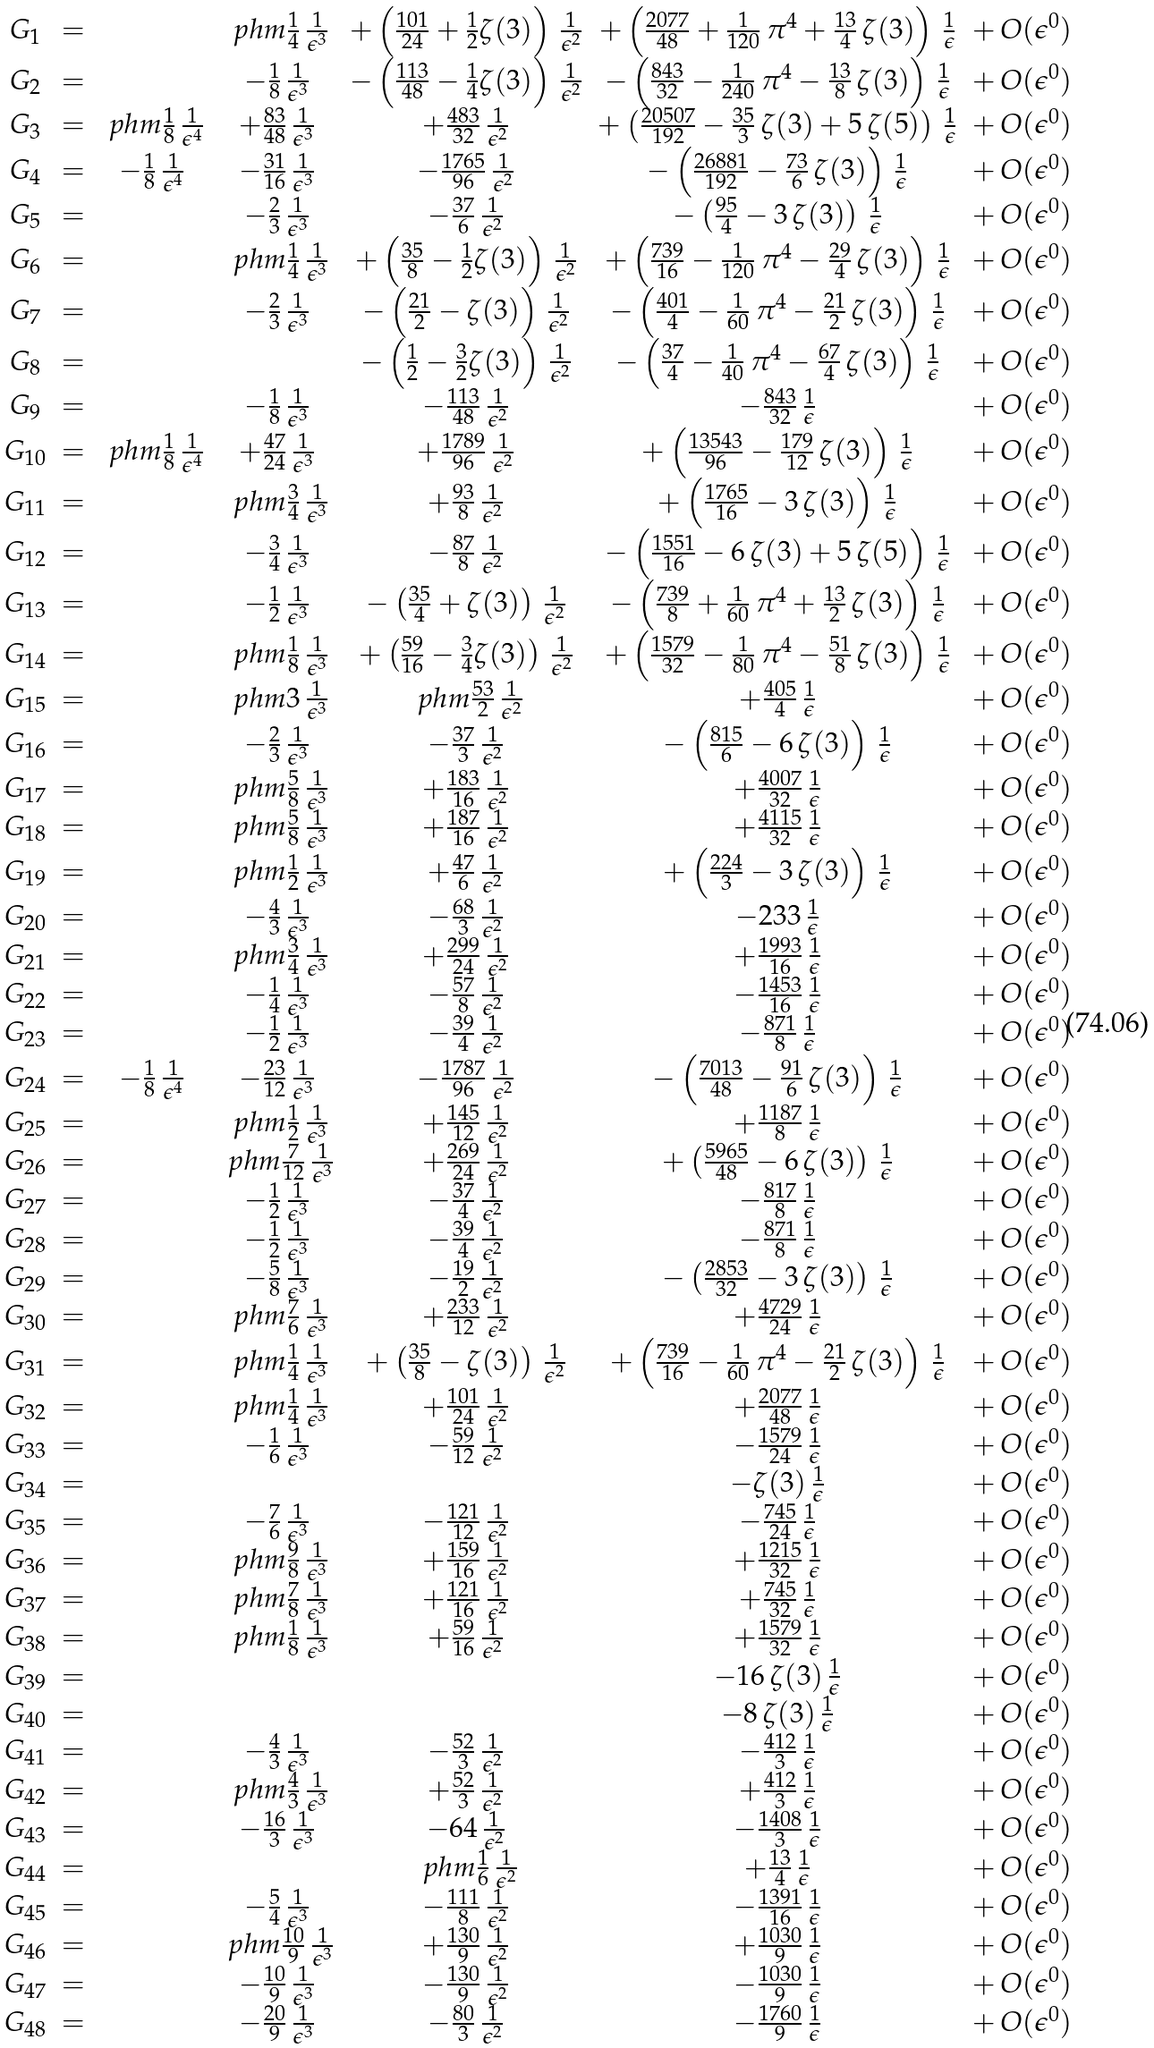Convert formula to latex. <formula><loc_0><loc_0><loc_500><loc_500>\begin{array} { c c c c c c c } G _ { 1 } & = & & \ p h m \frac { 1 } { 4 } \, \frac { 1 } { \epsilon ^ { 3 } } & + \left ( \frac { 1 0 1 } { 2 4 } + \frac { 1 } { 2 } { \text {$\zeta(3)$} } \right ) \, \frac { 1 } { \epsilon ^ { 2 } } & + \left ( \frac { 2 0 7 7 } { 4 8 } + \frac { 1 } { 1 2 0 } \, \pi ^ { 4 } + \frac { 1 3 } { 4 } \, { \text {$\zeta(3)$} } \right ) \, \frac { 1 } { \epsilon } & + \, { \text {$O(\epsilon^{0})$} } \\ G _ { 2 } & = & & - \frac { 1 } { 8 } \, \frac { 1 } { \epsilon ^ { 3 } } & - \left ( \frac { 1 1 3 } { 4 8 } - \frac { 1 } { 4 } { \text {$\zeta(3)$} } \right ) \, \frac { 1 } { \epsilon ^ { 2 } } & - \left ( \frac { 8 4 3 } { 3 2 } - \frac { 1 } { 2 4 0 } \, \pi ^ { 4 } - \frac { 1 3 } { 8 } \, { \text {$\zeta(3)$} } \right ) \, \frac { 1 } { \epsilon } & + \, { \text {$O(\epsilon^{0})$} } \\ G _ { 3 } & = & \ p h m \frac { 1 } { 8 } \, \frac { 1 } { \epsilon ^ { 4 } } & + \frac { 8 3 } { 4 8 } \, \frac { 1 } { \epsilon ^ { 3 } } & + \frac { 4 8 3 } { 3 2 } \, \frac { 1 } { \epsilon ^ { 2 } } & + \left ( \frac { 2 0 5 0 7 } { 1 9 2 } - \frac { 3 5 } { 3 } \, { \text {$\zeta(3)$} } + { \text {$5 \, \zeta (5)$} } \right ) \, \frac { 1 } { \epsilon } & + \, { \text {$O(\epsilon^{0})$} } \\ G _ { 4 } & = & - \frac { 1 } { 8 } \, \frac { 1 } { \epsilon ^ { 4 } } & - \frac { 3 1 } { 1 6 } \, \frac { 1 } { \epsilon ^ { 3 } } & - \frac { 1 7 6 5 } { 9 6 } \, \frac { 1 } { \epsilon ^ { 2 } } & - \left ( \frac { 2 6 8 8 1 } { 1 9 2 } - \frac { 7 3 } { 6 } \, { \text {$\zeta(3)$} } \right ) \, \frac { 1 } { \epsilon } & + \, { \text {$O(\epsilon^{0})$} } \\ G _ { 5 } & = & & - \frac { 2 } { 3 } \, \frac { 1 } { \epsilon ^ { 3 } } & - \frac { 3 7 } { 6 } \, \frac { 1 } { \epsilon ^ { 2 } } & - \left ( \frac { 9 5 } { 4 } - { \text {$3 \, \zeta(3)$} } \right ) \, \frac { 1 } { \epsilon } & + \, { \text {$O(\epsilon^{0})$} } \\ G _ { 6 } & = & & \ p h m \frac { 1 } { 4 } \, \frac { 1 } { \epsilon ^ { 3 } } & + \left ( \frac { 3 5 } { 8 } - \frac { 1 } { 2 } { \text {$\zeta(3)$} } \right ) \, \frac { 1 } { \epsilon ^ { 2 } } & + \left ( \frac { 7 3 9 } { 1 6 } - \frac { 1 } { 1 2 0 } \, \pi ^ { 4 } - \frac { 2 9 } { 4 } \, { \text {$\zeta(3)$} } \right ) \, \frac { 1 } { \epsilon } & + \, { \text {$O(\epsilon^{0})$} } \\ G _ { 7 } & = & & - \frac { 2 } { 3 } \, \frac { 1 } { \epsilon ^ { 3 } } & - \left ( \frac { 2 1 } { 2 } - { \text {$\zeta(3)$} } \right ) \, \frac { 1 } { \epsilon ^ { 2 } } & - \left ( \frac { 4 0 1 } { 4 } - \frac { 1 } { 6 0 } \, \pi ^ { 4 } - \frac { 2 1 } { 2 } \, { \text {$\zeta(3)$} } \right ) \, \frac { 1 } { \epsilon } & + \, { \text {$O(\epsilon^{0})$} } \\ G _ { 8 } & = & & & - \left ( \frac { 1 } { 2 } - \frac { 3 } { 2 } { \text {$\zeta(3)$} } \right ) \, \frac { 1 } { \epsilon ^ { 2 } } & - \left ( \frac { 3 7 } { 4 } - \frac { 1 } { 4 0 } \, \pi ^ { 4 } - \frac { 6 7 } { 4 } \, { \text {$\zeta(3)$} } \right ) \, \frac { 1 } { \epsilon } & + \, { \text {$O(\epsilon^{0})$} } \\ G _ { 9 } & = & & - \frac { 1 } { 8 } \, \frac { 1 } { \epsilon ^ { 3 } } & - \frac { 1 1 3 } { 4 8 } \, \frac { 1 } { \epsilon ^ { 2 } } & - \frac { 8 4 3 } { 3 2 } \, \frac { 1 } { \epsilon } & + \, { \text {$O(\epsilon^{0})$} } \\ G _ { 1 0 } & = & \ p h m \frac { 1 } { 8 } \, \frac { 1 } { \epsilon ^ { 4 } } & + \frac { 4 7 } { 2 4 } \, \frac { 1 } { \epsilon ^ { 3 } } & + \frac { 1 7 8 9 } { 9 6 } \, \frac { 1 } { \epsilon ^ { 2 } } & + \left ( \frac { 1 3 5 4 3 } { 9 6 } - \frac { 1 7 9 } { 1 2 } \, { \text {$\zeta(3)$} } \right ) \, \frac { 1 } { \epsilon } & + \, { \text {$O(\epsilon^{0})$} } \\ G _ { 1 1 } & = & & \ p h m \frac { 3 } { 4 } \, \frac { 1 } { \epsilon ^ { 3 } } & + \frac { 9 3 } { 8 } \, \frac { 1 } { \epsilon ^ { 2 } } & + \left ( \frac { 1 7 6 5 } { 1 6 } - { \text {$3 \, \zeta(3)$} } \right ) \, \frac { 1 } { \epsilon } & + \, { \text {$O(\epsilon^{0})$} } \\ G _ { 1 2 } & = & & - \frac { 3 } { 4 } \, \frac { 1 } { \epsilon ^ { 3 } } & - \frac { 8 7 } { 8 } \, \frac { 1 } { \epsilon ^ { 2 } } & - \left ( \frac { 1 5 5 1 } { 1 6 } - { \text {$6 \, \zeta(3)$} } + { \text {$5 \, \zeta (5)$} } \right ) \, \frac { 1 } { \epsilon } & + \, { \text {$O(\epsilon^{0})$} } \\ G _ { 1 3 } & = & & - \frac { 1 } { 2 } \, \frac { 1 } { \epsilon ^ { 3 } } & - \left ( \frac { 3 5 } { 4 } + { \text {$\zeta(3)$} } \right ) \, \frac { 1 } { \epsilon ^ { 2 } } & - \left ( \frac { 7 3 9 } { 8 } + \frac { 1 } { 6 0 } \, \pi ^ { 4 } + \frac { 1 3 } { 2 } \, { \text {$\zeta(3)$} } \right ) \, \frac { 1 } { \epsilon } & + \, { \text {$O(\epsilon^{0})$} } \\ G _ { 1 4 } & = & & \ p h m \frac { 1 } { 8 } \, \frac { 1 } { \epsilon ^ { 3 } } & + \left ( \frac { 5 9 } { 1 6 } - \frac { 3 } { 4 } { \text {$\zeta(3)$} } \right ) \, \frac { 1 } { \epsilon ^ { 2 } } & + \left ( \frac { 1 5 7 9 } { 3 2 } - \frac { 1 } { 8 0 } \, \pi ^ { 4 } - \frac { 5 1 } { 8 } \, { \text {$\zeta(3)$} } \right ) \, \frac { 1 } { \epsilon } & + \, { \text {$O(\epsilon^{0})$} } \\ G _ { 1 5 } & = & & \ p h m { \text {3} } \, \frac { 1 } { \epsilon ^ { 3 } } & \ p h m \frac { 5 3 } { 2 } \, \frac { 1 } { \epsilon ^ { 2 } } & + \frac { 4 0 5 } { 4 } \, \frac { 1 } { \epsilon } & + \, { \text {$O(\epsilon^{0})$} } \\ G _ { 1 6 } & = & & - \frac { 2 } { 3 } \, \frac { 1 } { \epsilon ^ { 3 } } & - \frac { 3 7 } { 3 } \, \frac { 1 } { \epsilon ^ { 2 } } & - \left ( \frac { 8 1 5 } { 6 } - { \text {$6 \, \zeta(3)$} } \right ) \, \frac { 1 } { \epsilon } & + \, { \text {$O(\epsilon^{0})$} } \\ G _ { 1 7 } & = & & \ p h m \frac { 5 } { 8 } \, \frac { 1 } { \epsilon ^ { 3 } } & + \frac { 1 8 3 } { 1 6 } \, \frac { 1 } { \epsilon ^ { 2 } } & + \frac { 4 0 0 7 } { 3 2 } \, \frac { 1 } { \epsilon } & + \, { \text {$O(\epsilon^{0})$} } \\ G _ { 1 8 } & = & & \ p h m \frac { 5 } { 8 } \, \frac { 1 } { \epsilon ^ { 3 } } & + \frac { 1 8 7 } { 1 6 } \, \frac { 1 } { \epsilon ^ { 2 } } & + \frac { 4 1 1 5 } { 3 2 } \, \frac { 1 } { \epsilon } & + \, { \text {$O(\epsilon^{0})$} } \\ G _ { 1 9 } & = & & \ p h m \frac { 1 } { 2 } \, \frac { 1 } { \epsilon ^ { 3 } } & + \frac { 4 7 } { 6 } \, \frac { 1 } { \epsilon ^ { 2 } } & + \left ( \frac { 2 2 4 } { 3 } - { \text {$3 \, \zeta(3)$} } \right ) \, \frac { 1 } { \epsilon } & + \, { \text {$O(\epsilon^{0})$} } \\ G _ { 2 0 } & = & & - \frac { 4 } { 3 } \, \frac { 1 } { \epsilon ^ { 3 } } & - \frac { 6 8 } { 3 } \, \frac { 1 } { \epsilon ^ { 2 } } & - { \text {233} } \, \frac { 1 } { \epsilon } & + \, { \text {$O(\epsilon^{0})$} } \\ G _ { 2 1 } & = & & \ p h m \frac { 3 } { 4 } \, \frac { 1 } { \epsilon ^ { 3 } } & + \frac { 2 9 9 } { 2 4 } \, \frac { 1 } { \epsilon ^ { 2 } } & + \frac { 1 9 9 3 } { 1 6 } \, \frac { 1 } { \epsilon } & + \, { \text {$O(\epsilon^{0})$} } \\ G _ { 2 2 } & = & & - \frac { 1 } { 4 } \, \frac { 1 } { \epsilon ^ { 3 } } & - \frac { 5 7 } { 8 } \, \frac { 1 } { \epsilon ^ { 2 } } & - \frac { 1 4 5 3 } { 1 6 } \, \frac { 1 } { \epsilon } & + \, { \text {$O(\epsilon^{0})$} } \\ G _ { 2 3 } & = & & - \frac { 1 } { 2 } \, \frac { 1 } { \epsilon ^ { 3 } } & - \frac { 3 9 } { 4 } \, \frac { 1 } { \epsilon ^ { 2 } } & - \frac { 8 7 1 } { 8 } \, \frac { 1 } { \epsilon } & + \, { \text {$O(\epsilon^{0})$} } \\ G _ { 2 4 } & = & - \frac { 1 } { 8 } \, \frac { 1 } { \epsilon ^ { 4 } } & - \frac { 2 3 } { 1 2 } \, \frac { 1 } { \epsilon ^ { 3 } } & - \frac { 1 7 8 7 } { 9 6 } \, \frac { 1 } { \epsilon ^ { 2 } } & - \left ( \frac { 7 0 1 3 } { 4 8 } - \frac { 9 1 } { 6 } \, { \text {$\zeta(3)$} } \right ) \, \frac { 1 } { \epsilon } & + \, { \text {$O(\epsilon^{0})$} } \\ G _ { 2 5 } & = & & \ p h m \frac { 1 } { 2 } \, \frac { 1 } { \epsilon ^ { 3 } } & + \frac { 1 4 5 } { 1 2 } \, \frac { 1 } { \epsilon ^ { 2 } } & + \frac { 1 1 8 7 } { 8 } \, \frac { 1 } { \epsilon } & + \, { \text {$O(\epsilon^{0})$} } \\ G _ { 2 6 } & = & & \ p h m \frac { 7 } { 1 2 } \, \frac { 1 } { \epsilon ^ { 3 } } & + \frac { 2 6 9 } { 2 4 } \, \frac { 1 } { \epsilon ^ { 2 } } & + \left ( \frac { 5 9 6 5 } { 4 8 } - { \text {$6 \, \zeta(3)$} } \right ) \, \frac { 1 } { \epsilon } & + \, { \text {$O(\epsilon^{0})$} } \\ G _ { 2 7 } & = & & - \frac { 1 } { 2 } \, \frac { 1 } { \epsilon ^ { 3 } } & - \frac { 3 7 } { 4 } \, \frac { 1 } { \epsilon ^ { 2 } } & - \frac { 8 1 7 } { 8 } \, \frac { 1 } { \epsilon } & + \, { \text {$O(\epsilon^{0})$} } \\ G _ { 2 8 } & = & & - \frac { 1 } { 2 } \, \frac { 1 } { \epsilon ^ { 3 } } & - \frac { 3 9 } { 4 } \, \frac { 1 } { \epsilon ^ { 2 } } & - \frac { 8 7 1 } { 8 } \, \frac { 1 } { \epsilon } & + \, { \text {$O(\epsilon^{0})$} } \\ G _ { 2 9 } & = & & - \frac { 5 } { 8 } \, \frac { 1 } { \epsilon ^ { 3 } } & - \frac { 1 9 } { 2 } \, \frac { 1 } { \epsilon ^ { 2 } } & - \left ( \frac { 2 8 5 3 } { 3 2 } - { \text {$3 \, \zeta(3)$} } \right ) \, \frac { 1 } { \epsilon } & + \, { \text {$O(\epsilon^{0})$} } \\ G _ { 3 0 } & = & & \ p h m \frac { 7 } { 6 } \, \frac { 1 } { \epsilon ^ { 3 } } & + \frac { 2 3 3 } { 1 2 } \, \frac { 1 } { \epsilon ^ { 2 } } & + \frac { 4 7 2 9 } { 2 4 } \, \frac { 1 } { \epsilon } & + \, { \text {$O(\epsilon^{0})$} } \\ G _ { 3 1 } & = & & \ p h m \frac { 1 } { 4 } \, \frac { 1 } { \epsilon ^ { 3 } } & + \left ( \frac { 3 5 } { 8 } - { \text {$\zeta(3)$} } \right ) \, \frac { 1 } { \epsilon ^ { 2 } } & + \left ( \frac { 7 3 9 } { 1 6 } - \frac { 1 } { 6 0 } \, \pi ^ { 4 } - \frac { 2 1 } { 2 } \, { \text {$\zeta(3)$} } \right ) \, \frac { 1 } { \epsilon } & + \, { \text {$O(\epsilon^{0})$} } \\ G _ { 3 2 } & = & & \ p h m \frac { 1 } { 4 } \, \frac { 1 } { \epsilon ^ { 3 } } & + \frac { 1 0 1 } { 2 4 } \, \frac { 1 } { \epsilon ^ { 2 } } & + \frac { 2 0 7 7 } { 4 8 } \, \frac { 1 } { \epsilon } & + \, { \text {$O(\epsilon^{0})$} } \\ G _ { 3 3 } & = & & - \frac { 1 } { 6 } \, \frac { 1 } { \epsilon ^ { 3 } } & - \frac { 5 9 } { 1 2 } \, \frac { 1 } { \epsilon ^ { 2 } } & - \frac { 1 5 7 9 } { 2 4 } \, \frac { 1 } { \epsilon } & + \, { \text {$O(\epsilon^{0})$} } \\ G _ { 3 4 } & = & & & & - { \text {$\zeta(3)$} } \, \frac { 1 } { \epsilon } & + \, { \text {$O(\epsilon^{0})$} } \\ G _ { 3 5 } & = & & - \frac { 7 } { 6 } \, \frac { 1 } { \epsilon ^ { 3 } } & - \frac { 1 2 1 } { 1 2 } \, \frac { 1 } { \epsilon ^ { 2 } } & - \frac { 7 4 5 } { 2 4 } \, \frac { 1 } { \epsilon } & + \, { \text {$O(\epsilon^{0})$} } \\ G _ { 3 6 } & = & & \ p h m \frac { 9 } { 8 } \, \frac { 1 } { \epsilon ^ { 3 } } & + \frac { 1 5 9 } { 1 6 } \, \frac { 1 } { \epsilon ^ { 2 } } & + \frac { 1 2 1 5 } { 3 2 } \, \frac { 1 } { \epsilon } & + \, { \text {$O(\epsilon^{0})$} } \\ G _ { 3 7 } & = & & \ p h m \frac { 7 } { 8 } \, \frac { 1 } { \epsilon ^ { 3 } } & + \frac { 1 2 1 } { 1 6 } \, \frac { 1 } { \epsilon ^ { 2 } } & + \frac { 7 4 5 } { 3 2 } \, \frac { 1 } { \epsilon } & + \, { \text {$O(\epsilon^{0})$} } \\ G _ { 3 8 } & = & & \ p h m \frac { 1 } { 8 } \, \frac { 1 } { \epsilon ^ { 3 } } & + \frac { 5 9 } { 1 6 } \, \frac { 1 } { \epsilon ^ { 2 } } & + \frac { 1 5 7 9 } { 3 2 } \, \frac { 1 } { \epsilon } & + \, { \text {$O(\epsilon^{0})$} } \\ G _ { 3 9 } & = & & & & - { \text {$16 \, \zeta(3)$} } \, \frac { 1 } { \epsilon } & + \, { \text {$O(\epsilon^{0})$} } \\ G _ { 4 0 } & = & & & & - { \text {$8 \, \zeta(3)$} } \, \frac { 1 } { \epsilon } & + \, { \text {$O(\epsilon^{0})$} } \\ G _ { 4 1 } & = & & - \frac { 4 } { 3 } \, \frac { 1 } { \epsilon ^ { 3 } } & - \frac { 5 2 } { 3 } \, \frac { 1 } { \epsilon ^ { 2 } } & - \frac { 4 1 2 } { 3 } \, \frac { 1 } { \epsilon } & + \, { \text {$O(\epsilon^{0})$} } \\ G _ { 4 2 } & = & & \ p h m \frac { 4 } { 3 } \, \frac { 1 } { \epsilon ^ { 3 } } & + \frac { 5 2 } { 3 } \, \frac { 1 } { \epsilon ^ { 2 } } & + \frac { 4 1 2 } { 3 } \, \frac { 1 } { \epsilon } & + \, { \text {$O(\epsilon^{0})$} } \\ G _ { 4 3 } & = & & - \frac { 1 6 } { 3 } \, \frac { 1 } { \epsilon ^ { 3 } } & - { \text {64} } \, \frac { 1 } { \epsilon ^ { 2 } } & - \frac { 1 4 0 8 } { 3 } \, \frac { 1 } { \epsilon } & + \, { \text {$O(\epsilon^{0})$} } \\ G _ { 4 4 } & = & & & \ p h m \frac { 1 } { 6 } \, \frac { 1 } { \epsilon ^ { 2 } } & + \frac { 1 3 } { 4 } \, \frac { 1 } { \epsilon } & + \, { \text {$O(\epsilon^{0})$} } \\ G _ { 4 5 } & = & & - \frac { 5 } { 4 } \, \frac { 1 } { \epsilon ^ { 3 } } & - \frac { 1 1 1 } { 8 } \, \frac { 1 } { \epsilon ^ { 2 } } & - \frac { 1 3 9 1 } { 1 6 } \, \frac { 1 } { \epsilon } & + \, { \text {$O(\epsilon^{0})$} } \\ G _ { 4 6 } & = & & \ p h m \frac { 1 0 } { 9 } \, \frac { 1 } { \epsilon ^ { 3 } } & + \frac { 1 3 0 } { 9 } \, \frac { 1 } { \epsilon ^ { 2 } } & + \frac { 1 0 3 0 } { 9 } \, \frac { 1 } { \epsilon } & + \, { \text {$O(\epsilon^{0})$} } \\ G _ { 4 7 } & = & & - \frac { 1 0 } { 9 } \, \frac { 1 } { \epsilon ^ { 3 } } & - \frac { 1 3 0 } { 9 } \, \frac { 1 } { \epsilon ^ { 2 } } & - \frac { 1 0 3 0 } { 9 } \, \frac { 1 } { \epsilon } & + \, { \text {$O(\epsilon^{0})$} } \\ G _ { 4 8 } & = & & - \frac { 2 0 } { 9 } \, \frac { 1 } { \epsilon ^ { 3 } } & - \frac { 8 0 } { 3 } \, \frac { 1 } { \epsilon ^ { 2 } } & - \frac { 1 7 6 0 } { 9 } \, \frac { 1 } { \epsilon } & + \, { \text {$O(\epsilon^{0})$} } \end{array}</formula> 